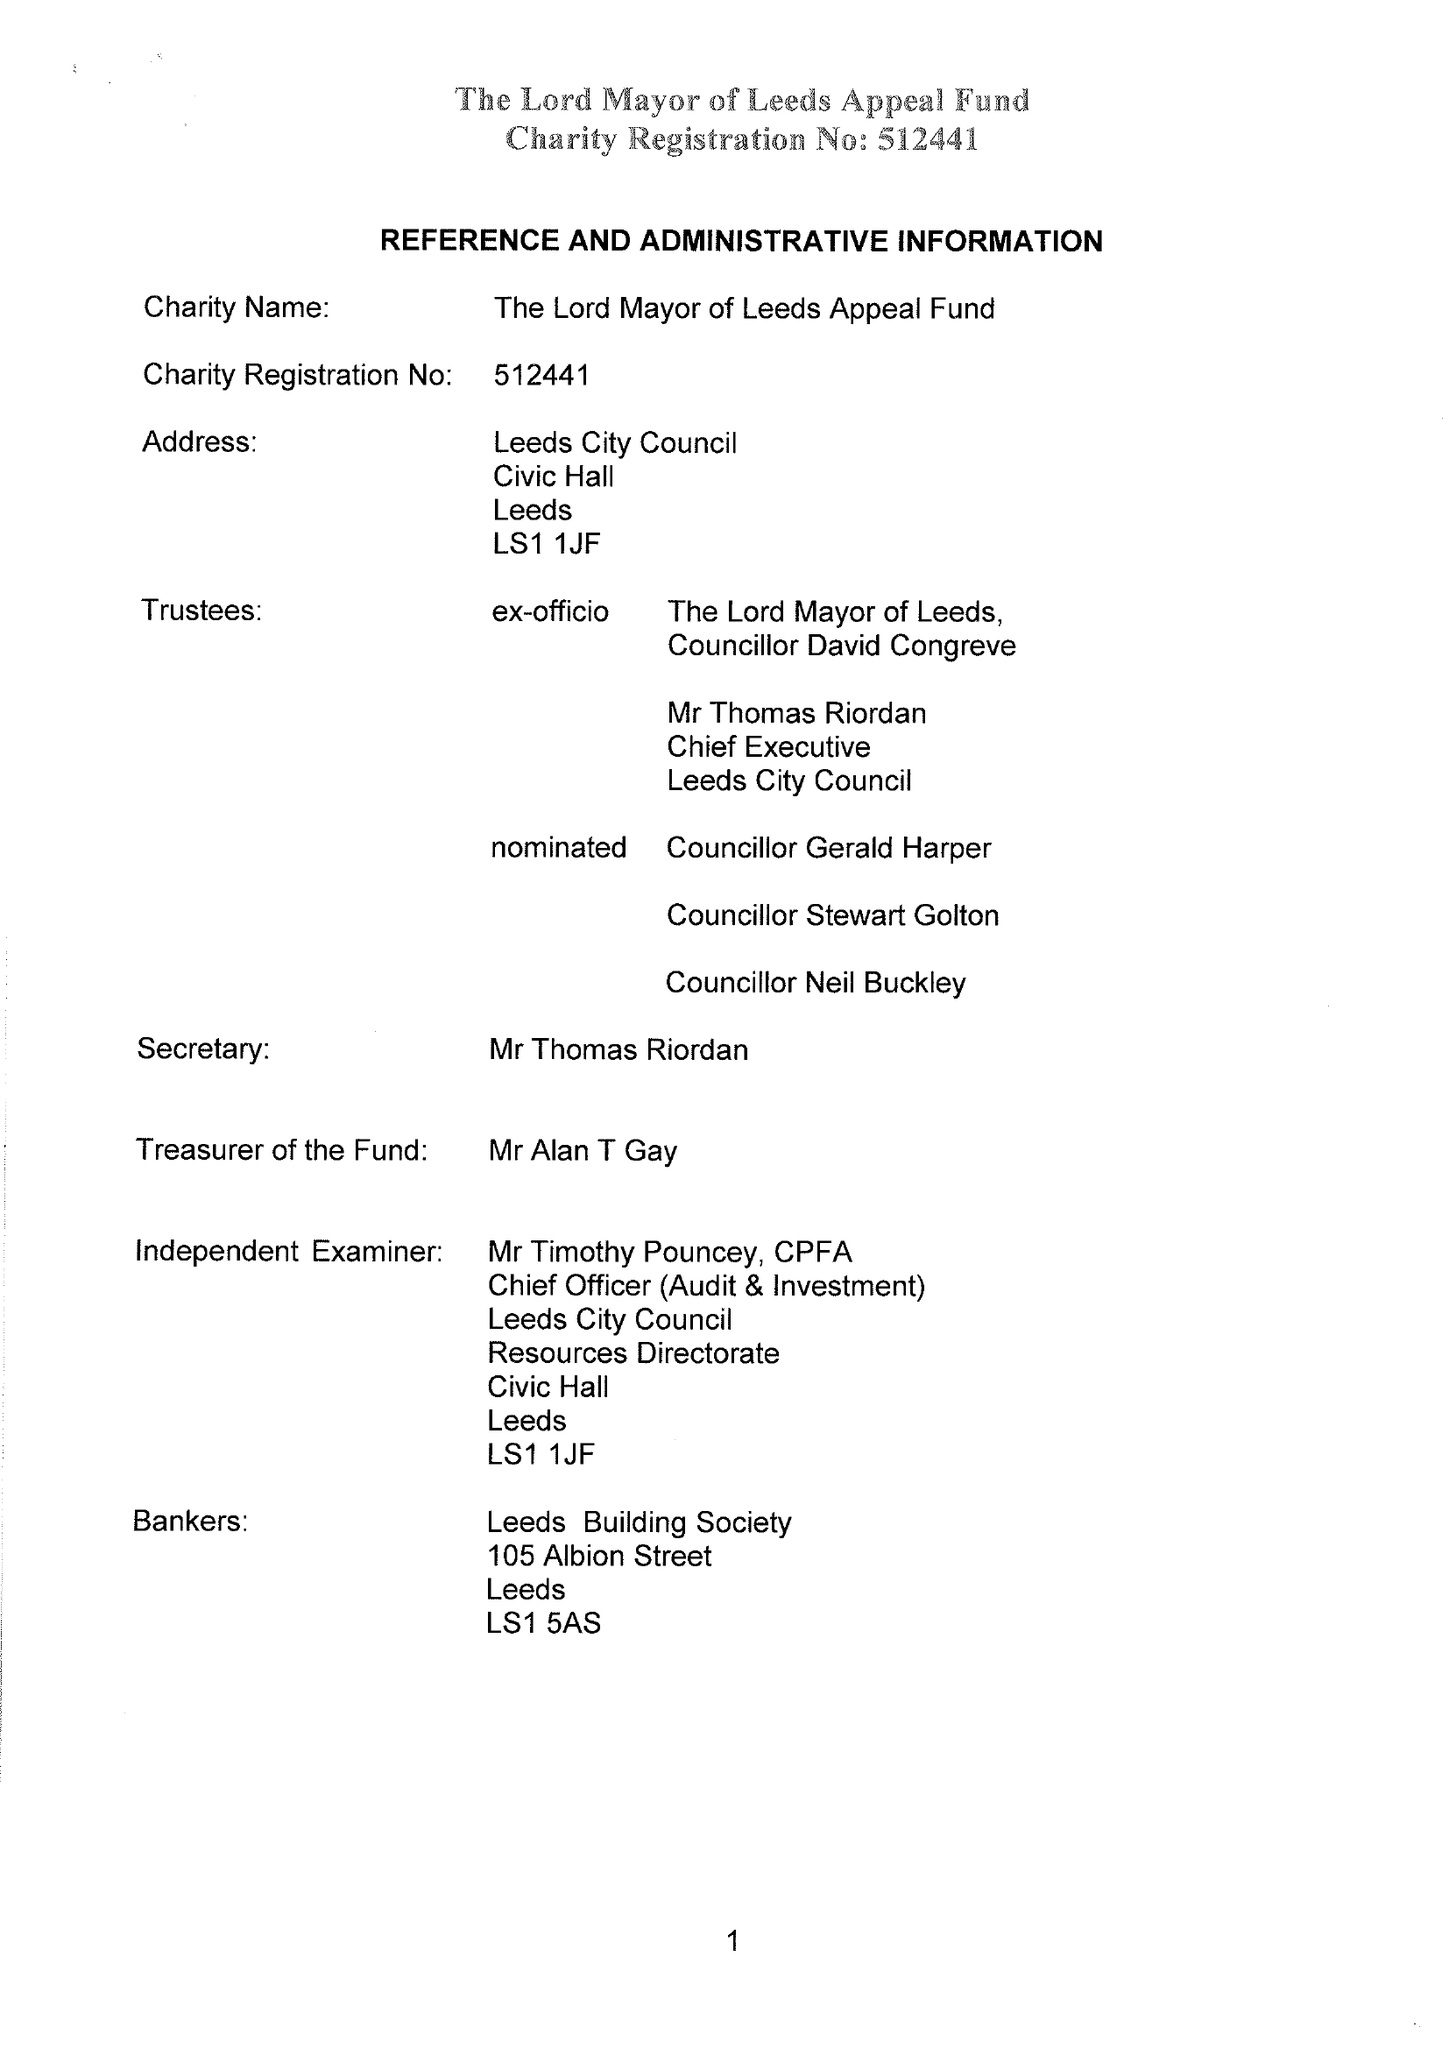What is the value for the charity_name?
Answer the question using a single word or phrase. Lord Mayor Of Leeds Appeal Fund 